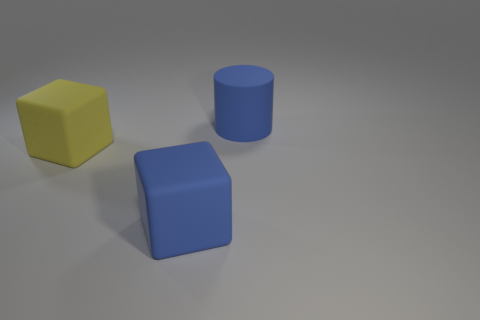The cube that is the same color as the big cylinder is what size?
Ensure brevity in your answer.  Large. There is a big thing that is the same color as the big rubber cylinder; what shape is it?
Ensure brevity in your answer.  Cube. The matte cylinder is what color?
Make the answer very short. Blue. The matte object in front of the big matte block that is left of the blue block that is on the right side of the yellow rubber object is what shape?
Provide a succinct answer. Cube. There is a large blue object behind the blue rubber thing that is to the left of the blue cylinder; what is its shape?
Give a very brief answer. Cylinder. Is there anything else that is the same color as the big rubber cylinder?
Provide a short and direct response. Yes. Do the yellow rubber thing and the thing right of the blue matte block have the same size?
Keep it short and to the point. Yes. What number of large things are either blue objects or rubber cylinders?
Keep it short and to the point. 2. Are there more objects than tiny shiny cylinders?
Provide a succinct answer. Yes. There is a big blue matte thing in front of the blue rubber object behind the yellow object; what number of blue blocks are in front of it?
Make the answer very short. 0. 